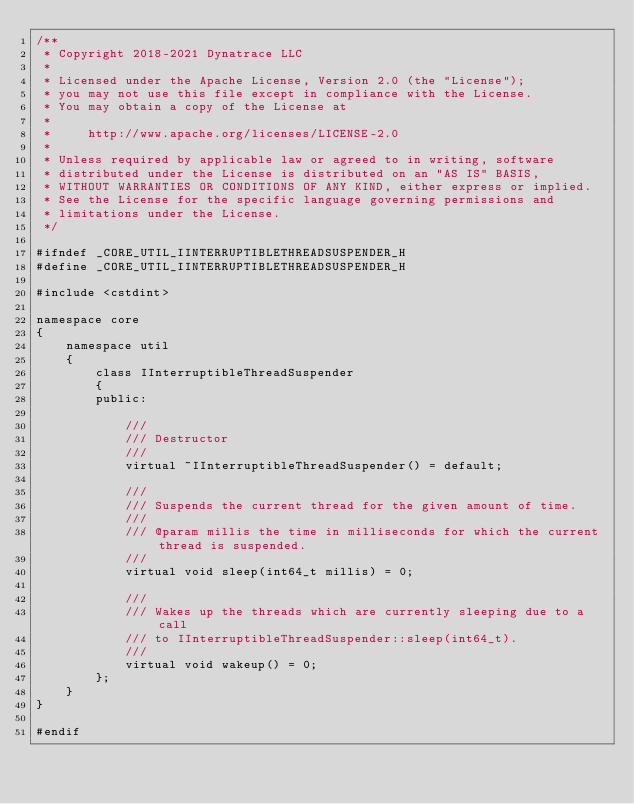Convert code to text. <code><loc_0><loc_0><loc_500><loc_500><_C_>/**
 * Copyright 2018-2021 Dynatrace LLC
 *
 * Licensed under the Apache License, Version 2.0 (the "License");
 * you may not use this file except in compliance with the License.
 * You may obtain a copy of the License at
 *
 *     http://www.apache.org/licenses/LICENSE-2.0
 *
 * Unless required by applicable law or agreed to in writing, software
 * distributed under the License is distributed on an "AS IS" BASIS,
 * WITHOUT WARRANTIES OR CONDITIONS OF ANY KIND, either express or implied.
 * See the License for the specific language governing permissions and
 * limitations under the License.
 */

#ifndef _CORE_UTIL_IINTERRUPTIBLETHREADSUSPENDER_H
#define _CORE_UTIL_IINTERRUPTIBLETHREADSUSPENDER_H

#include <cstdint>

namespace core
{
	namespace util
	{
		class IInterruptibleThreadSuspender
		{
		public:

			///
			/// Destructor
			///
			virtual ~IInterruptibleThreadSuspender() = default;

			///
			/// Suspends the current thread for the given amount of time. 
			///
			/// @param millis the time in milliseconds for which the current thread is suspended.
			///
			virtual void sleep(int64_t millis) = 0;

			///
			/// Wakes up the threads which are currently sleeping due to a call
			/// to IInterruptibleThreadSuspender::sleep(int64_t).
			///
			virtual void wakeup() = 0;
		};
	}
}

#endif
</code> 